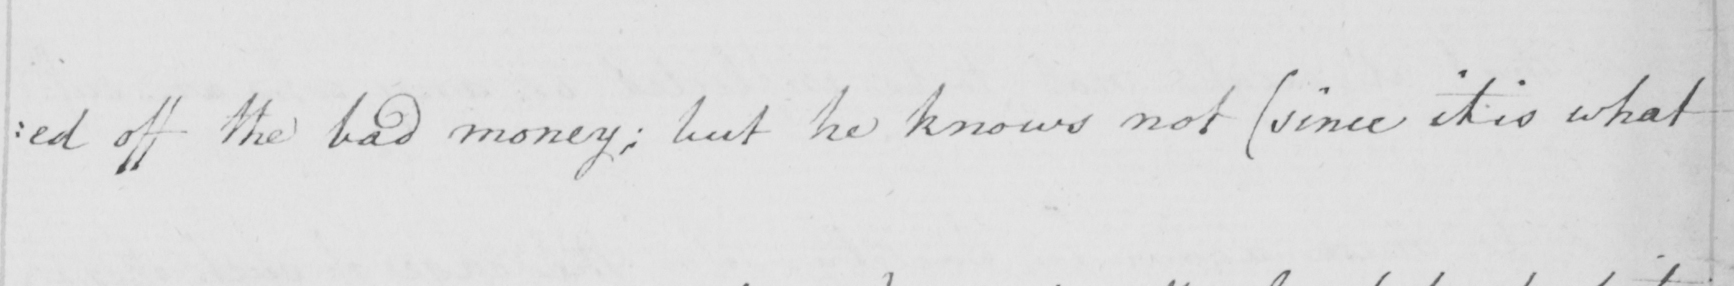What text is written in this handwritten line? : ed off the bad money ; but he knows not  ( since it is what 